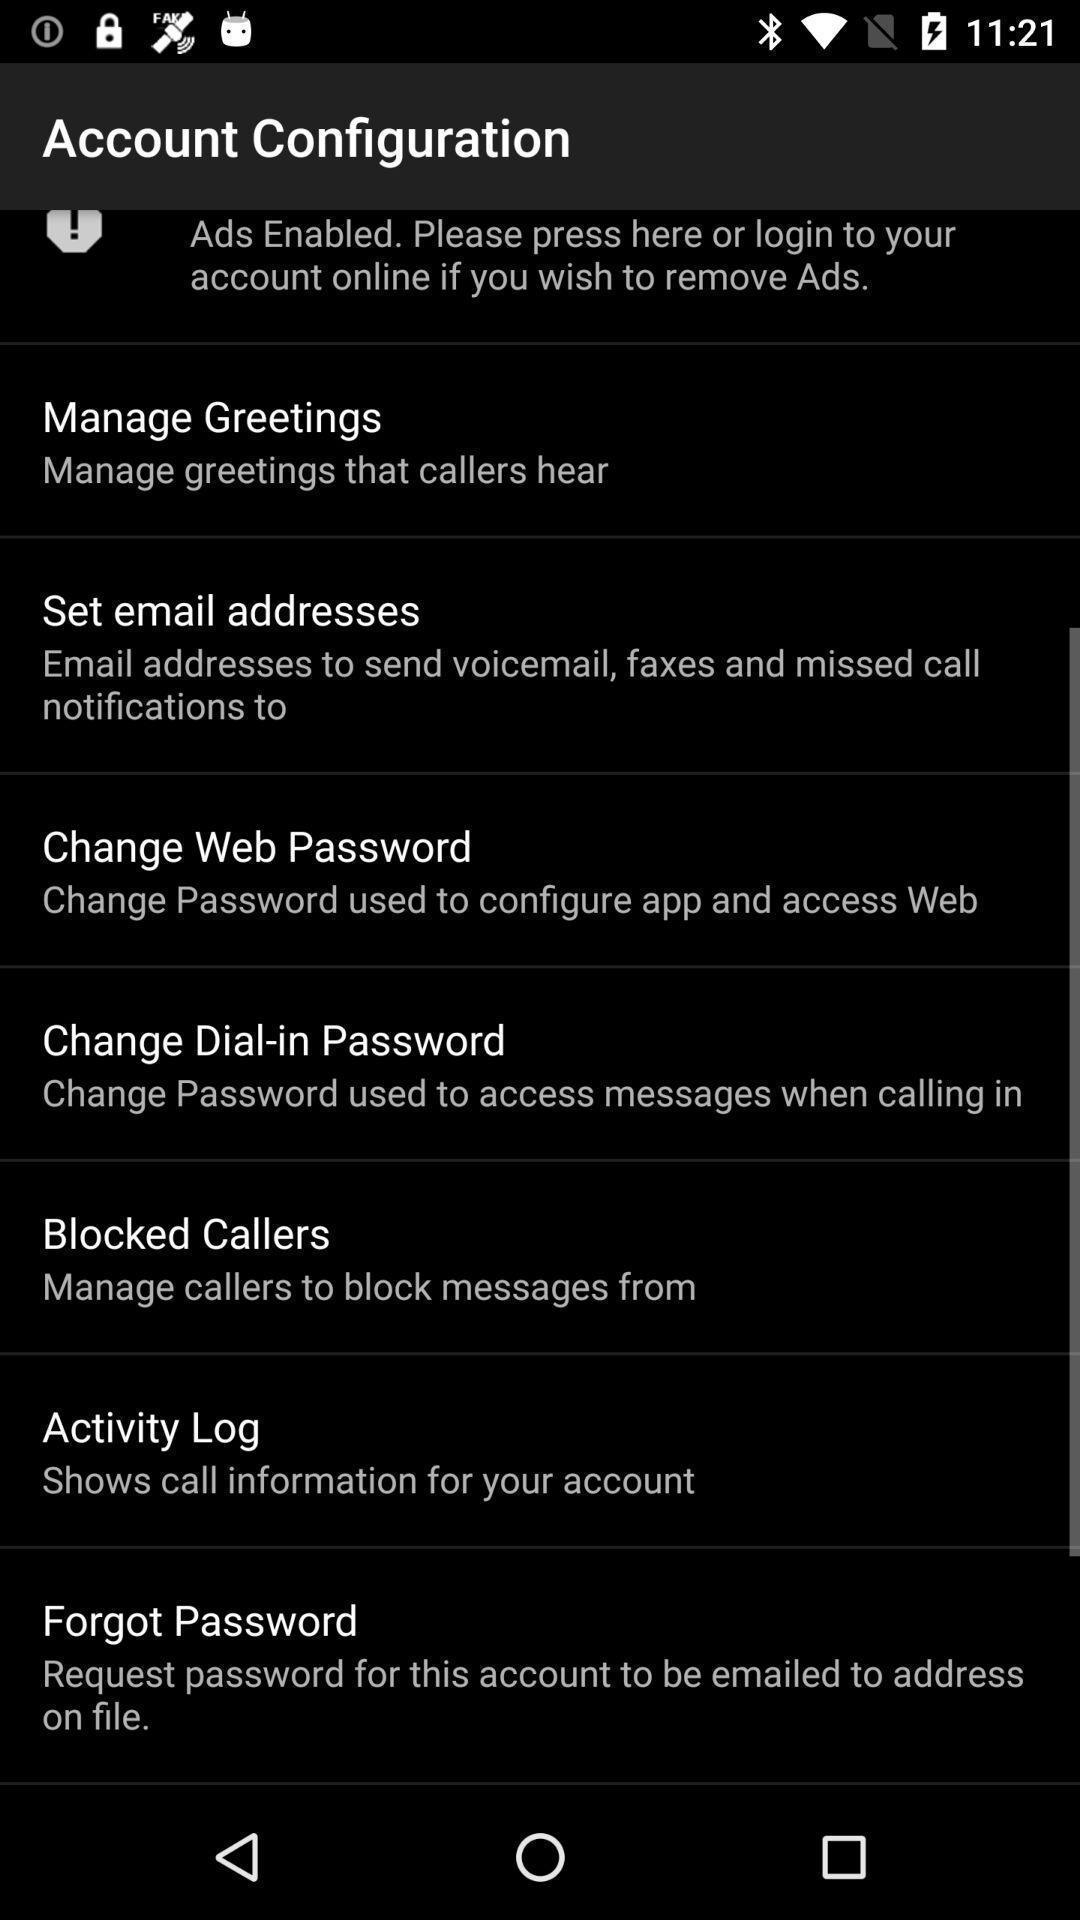Describe the content in this image. Settings page. 